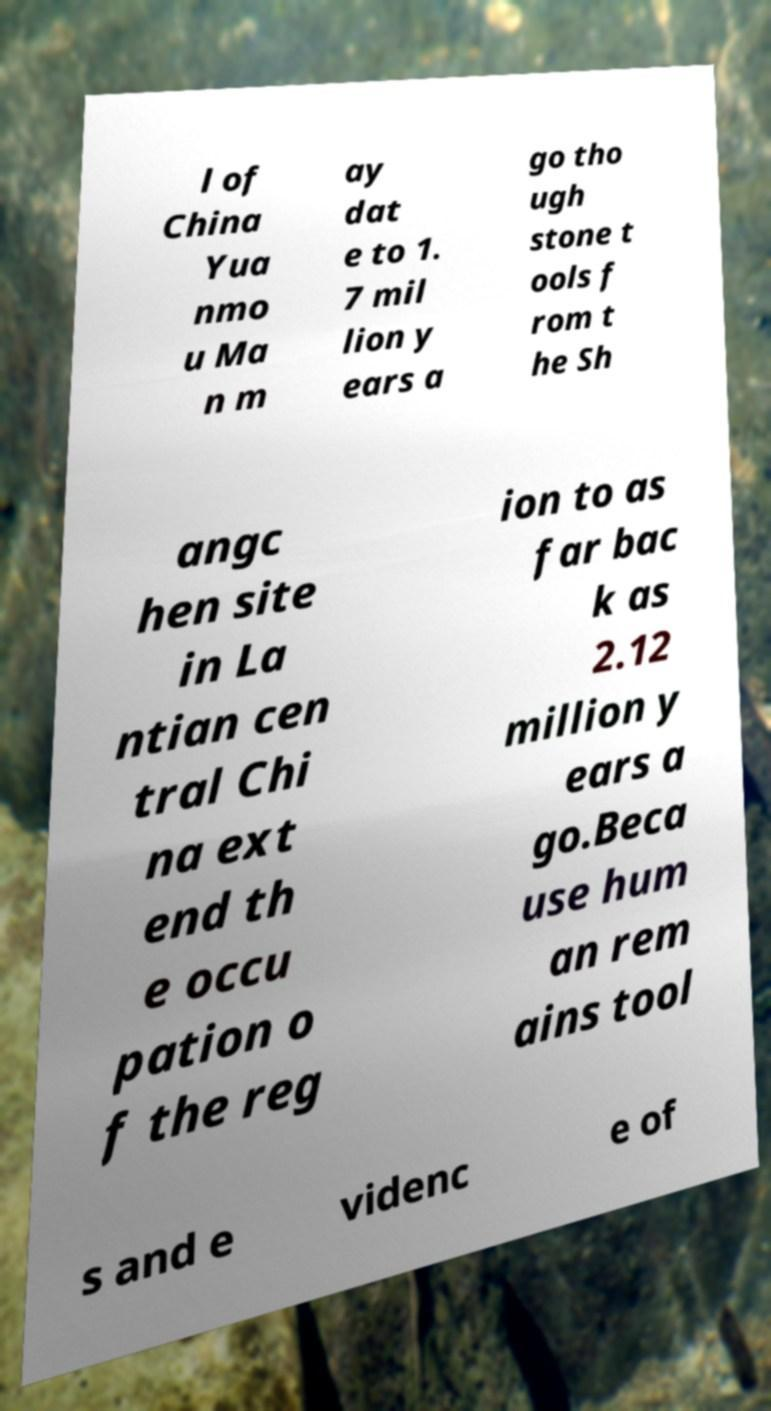Can you read and provide the text displayed in the image?This photo seems to have some interesting text. Can you extract and type it out for me? l of China Yua nmo u Ma n m ay dat e to 1. 7 mil lion y ears a go tho ugh stone t ools f rom t he Sh angc hen site in La ntian cen tral Chi na ext end th e occu pation o f the reg ion to as far bac k as 2.12 million y ears a go.Beca use hum an rem ains tool s and e videnc e of 